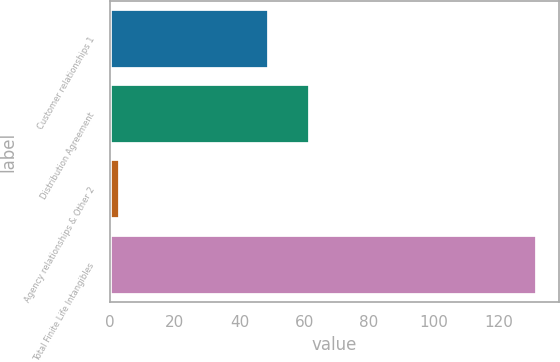Convert chart to OTSL. <chart><loc_0><loc_0><loc_500><loc_500><bar_chart><fcel>Customer relationships 1<fcel>Distribution Agreement<fcel>Agency relationships & Other 2<fcel>Total Finite Life Intangibles<nl><fcel>49<fcel>61.9<fcel>3<fcel>132<nl></chart> 